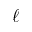Convert formula to latex. <formula><loc_0><loc_0><loc_500><loc_500>\ell</formula> 